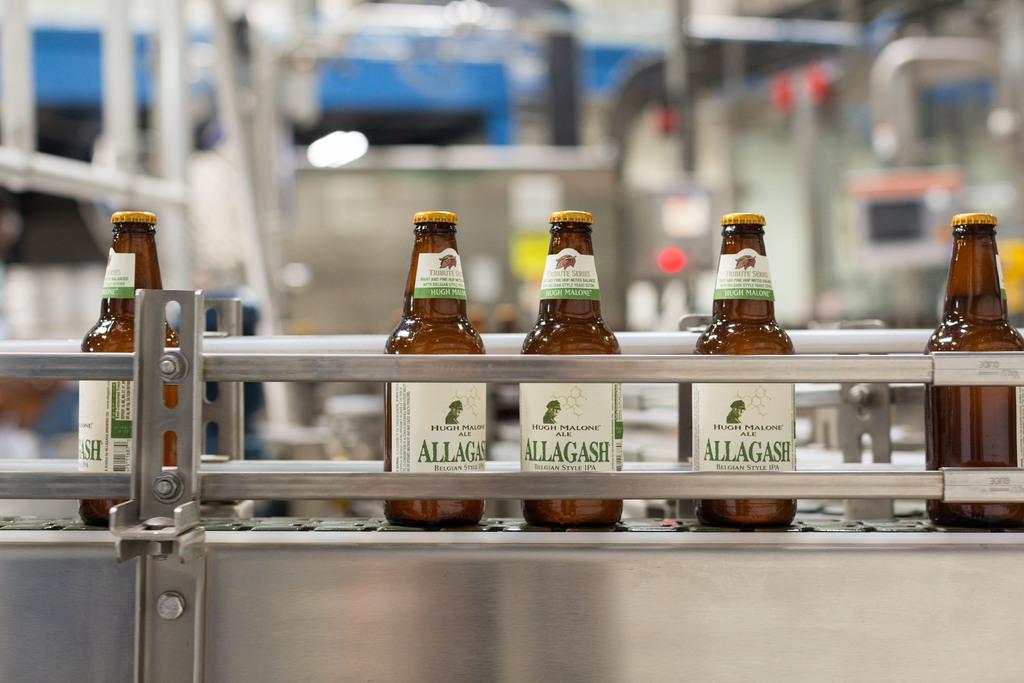What is the name of this ale?
Give a very brief answer. Allagash. 